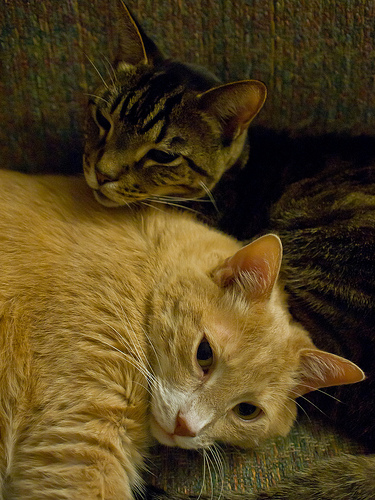<image>
Can you confirm if the baby cat is in front of the mother cat? No. The baby cat is not in front of the mother cat. The spatial positioning shows a different relationship between these objects. Is there a cat above the cat? Yes. The cat is positioned above the cat in the vertical space, higher up in the scene. 